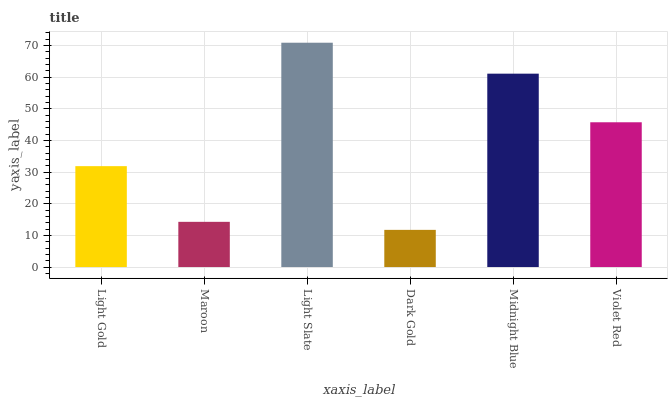Is Maroon the minimum?
Answer yes or no. No. Is Maroon the maximum?
Answer yes or no. No. Is Light Gold greater than Maroon?
Answer yes or no. Yes. Is Maroon less than Light Gold?
Answer yes or no. Yes. Is Maroon greater than Light Gold?
Answer yes or no. No. Is Light Gold less than Maroon?
Answer yes or no. No. Is Violet Red the high median?
Answer yes or no. Yes. Is Light Gold the low median?
Answer yes or no. Yes. Is Dark Gold the high median?
Answer yes or no. No. Is Midnight Blue the low median?
Answer yes or no. No. 